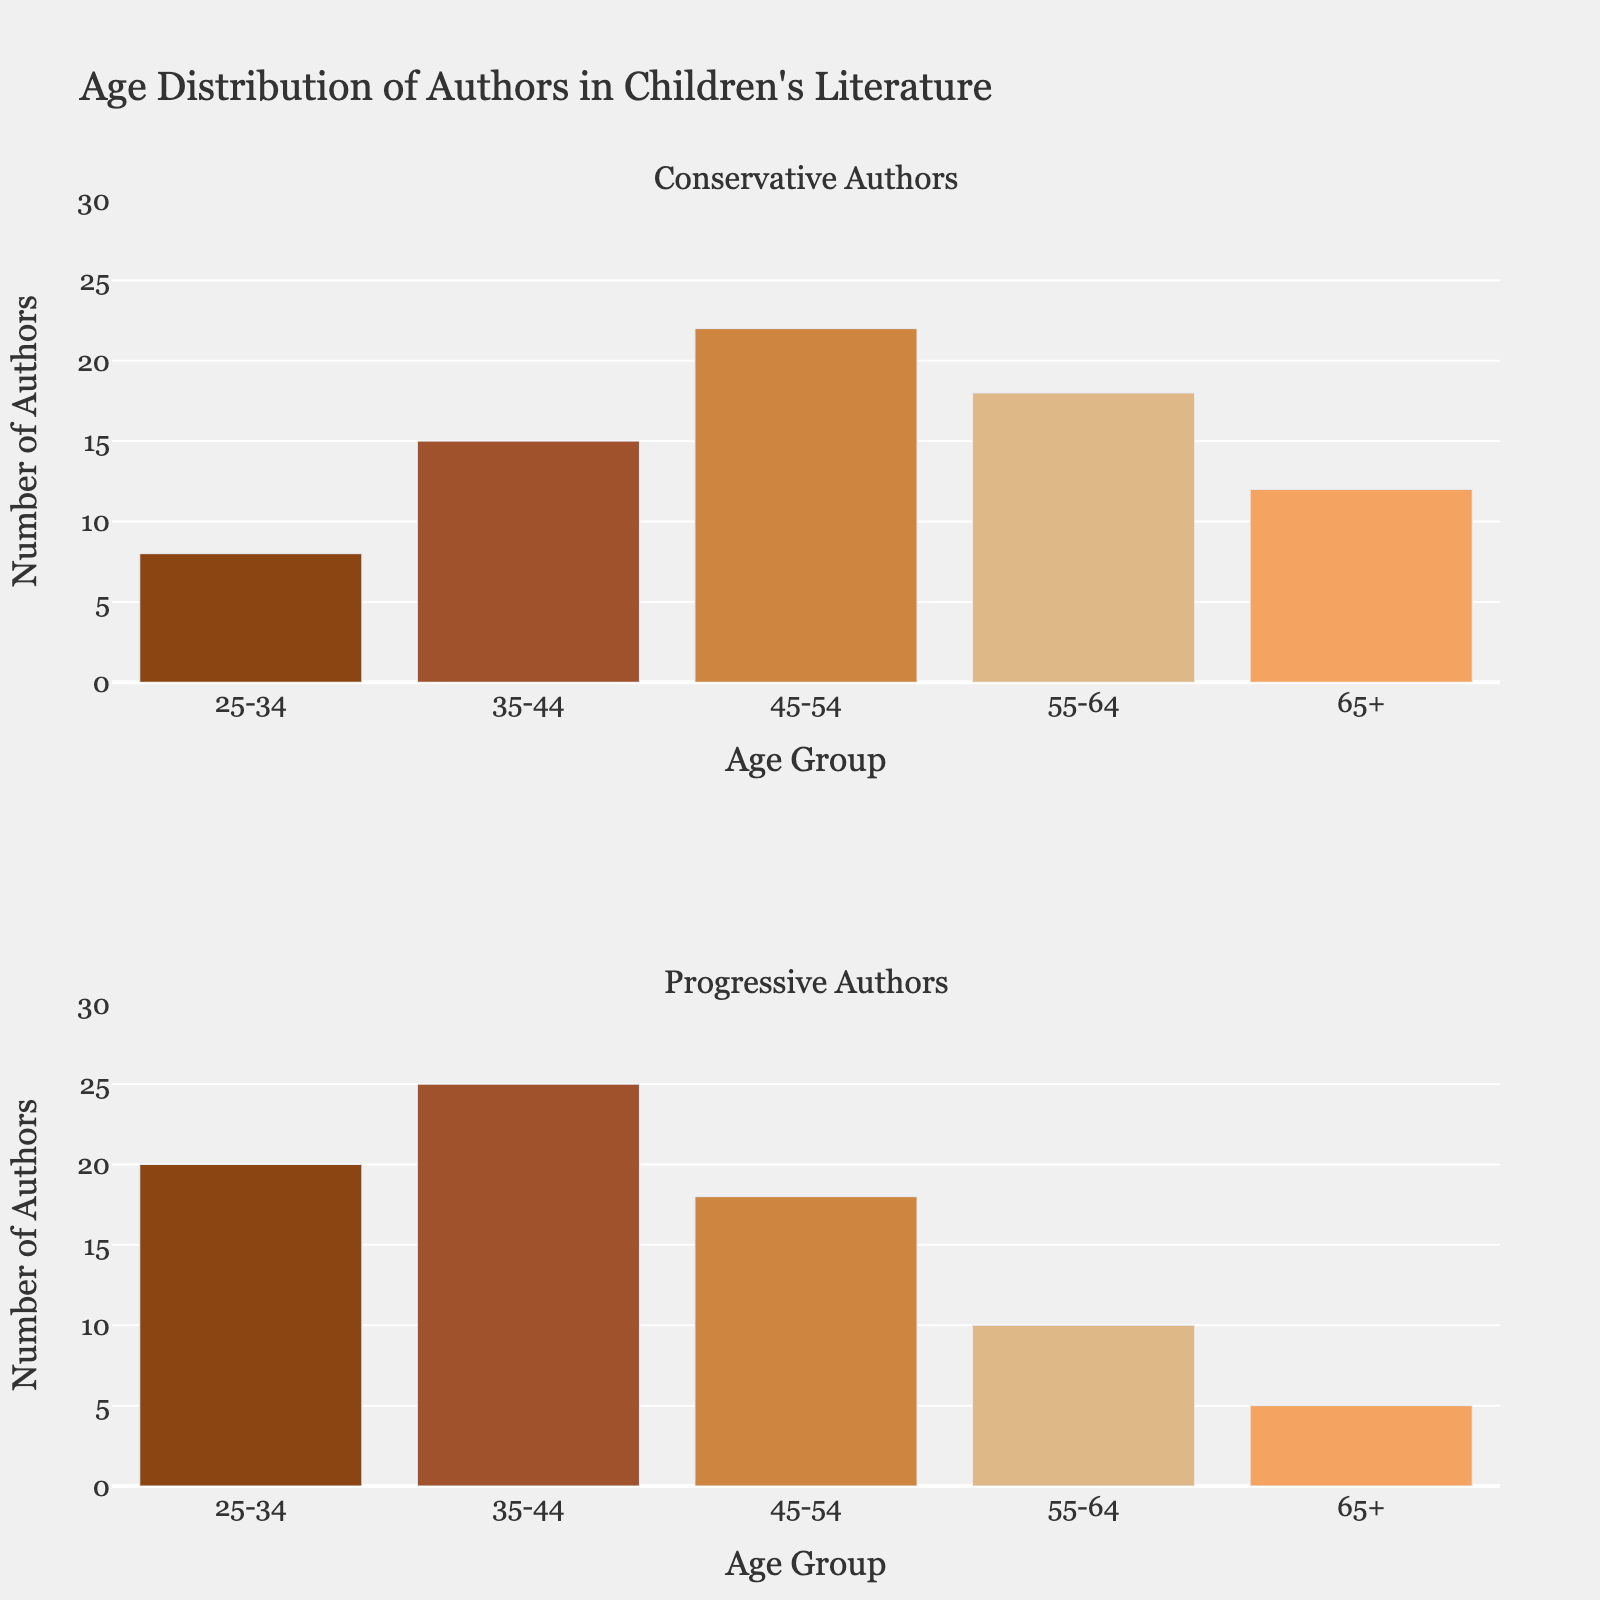what is the title of the figure? The title of the figure is located at the top of the plot and is designed to provide a brief description of what the figure represents. In this case, the title is "Age Distribution of Authors in Children's Literature".
Answer: Age Distribution of Authors in Children's Literature what are the age groups represented in the figure? Age groups are listed on the x-axes for both subplots and represent different age ranges of authors. The age groups are "25-34", "35-44", "45-54", "55-64", and "65+".
Answer: 25-34, 35-44, 45-54, 55-64, 65+ how many age groups are there for each category? Counting the distinct age groups labeled on the x-axes, there are a total of five age groups for each category (Conservative and Progressive).
Answer: 5 what color scheme is used for the bars in the figure? The bars in both subplots use a custom color palette consisting of different shades of brown. The colors range from dark brown to light brown.
Answer: different shades of brown how many authors in the 45-54 age group are from the conservative category? By looking at the first subplot (Conservative Authors) and finding the bar labeled "45-54", we see that its height represents 22 authors.
Answer: 22 which age group has the highest count of authors in the progressive category? Examining the second subplot (Progressive Authors), the bar for the "35-44" age group is the tallest, indicating the highest count of 25 authors.
Answer: 35-44 how many more authors are there in the 25-34 age group of the progressive category compared to the conservative category? The bar for the "25-34" age group in the Conservative category shows 8 authors, while in the Progressive category, it shows 20 authors. The difference is 20 - 8 = 12.
Answer: 12 what is the total number of conservative authors? Add the counts for each age group in the Conservative category: 8 (25-34) + 15 (35-44) + 22 (45-54) + 18 (55-64) + 12 (65+). The total is 75.
Answer: 75 which category has a greater number of authors in the age range 55-64? Comparing the bars for the age range "55-64" in both subplots, the Progressive category has 10 authors, while the Conservative category has 18 authors. Therefore, the Conservative category has more authors in this age range.
Answer: Conservative what is the average number of authors for the progressive category across all age groups? Sum the counts for each age group in the Progressive category and divide by the number of age groups. The average is (20 + 25 + 18 + 10 + 5) / 5 = 78 / 5 = 15.6.
Answer: 15.6 